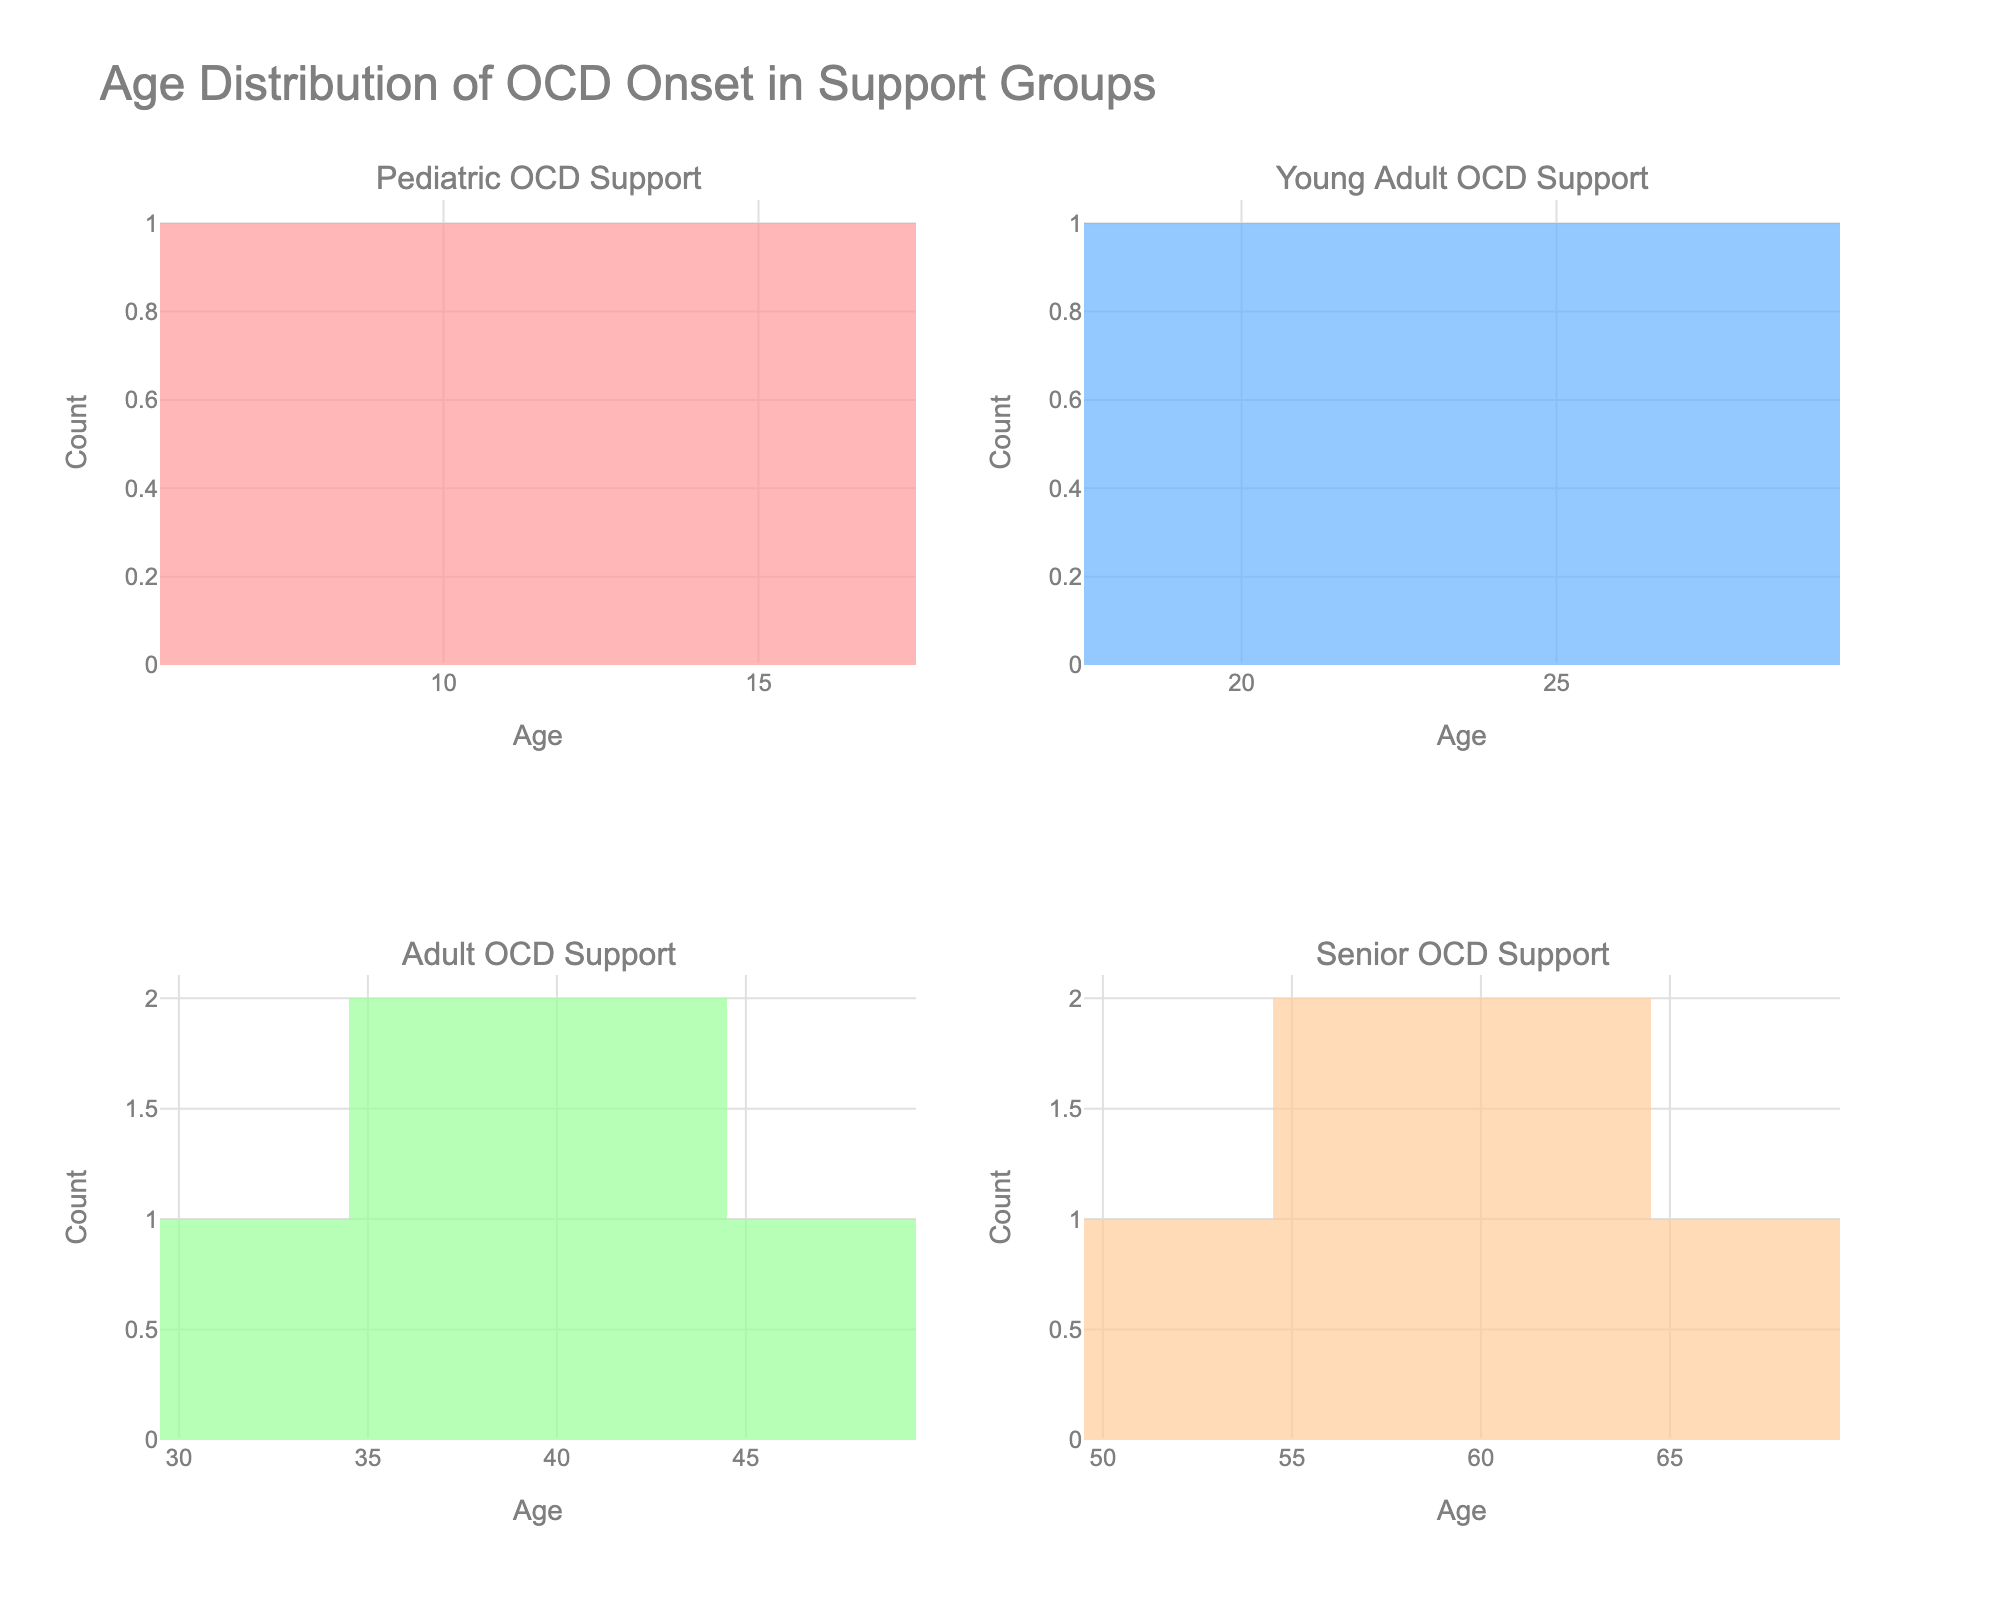What is the title of the figure? The title is displayed at the top of the figure and provides a summary of what the figure represents. The title reads "Age Distribution of OCD Onset in Support Groups."
Answer: Age Distribution of OCD Onset in Support Groups What does the x-axis represent in each subplot? The x-axis in each subplot represents the age of onset of OCD. This is indicated by the label "Age" on the x-axis of each subplot.
Answer: Age How many support groups are depicted in the figure, and what are their names? The figure contains four subplots, each named in the subplot titles. The support groups are "Pediatric OCD Support," "Young Adult OCD Support," "Adult OCD Support," and "Senior OCD Support."
Answer: Four; Pediatric OCD Support, Young Adult OCD Support, Adult OCD Support, Senior OCD Support Which support group shows the highest age range for the onset of OCD? By examining the x-axis range of each subplot, the "Senior OCD Support" group shows the highest age range, with ages ranging from 52 to 67.
Answer: Senior OCD Support Which age group has the highest frequency of OCD onset in the Pediatric OCD Support group? In the Pediatric OCD Support group histogram, the bar representing the age range of 15 has the highest frequency, indicating more individuals had OCD onset at this age.
Answer: 15 What is the age range depicted in the Young Adult OCD Support group? The x-axis of the Young Adult OCD Support group histogram shows that the ages range from 18 to 28.
Answer: 18-28 How many individuals are depicted in the Adult OCD Support group? By counting the individual bars in the Adult OCD Support group histogram and understanding each bar’s frequency, the total number of individuals (data points) is five.
Answer: 5 Is there any visible overlap in the age ranges among different support groups? By examining the age ranges on the x-axes of each subplot, there is no visible overlap in the age ranges among the different support groups. Each group has distinct age ranges.
Answer: No Which support group has the lowest age range for OCD onset? The Pediatric OCD Support group shows the lowest age range for OCD onset, starting from age 7.
Answer: Pediatric OCD Support 